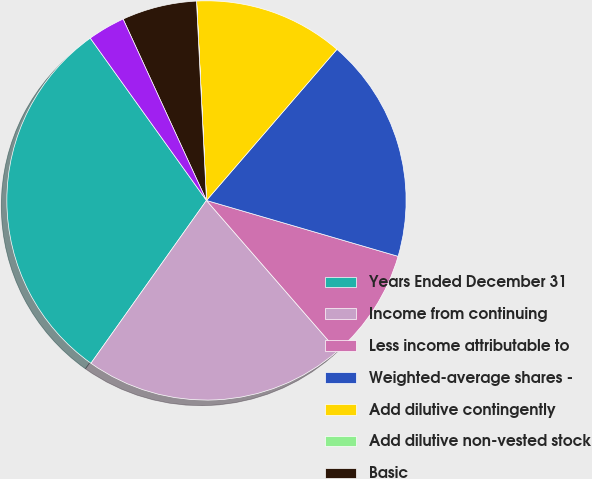Convert chart. <chart><loc_0><loc_0><loc_500><loc_500><pie_chart><fcel>Years Ended December 31<fcel>Income from continuing<fcel>Less income attributable to<fcel>Weighted-average shares -<fcel>Add dilutive contingently<fcel>Add dilutive non-vested stock<fcel>Basic<fcel>Diluted<nl><fcel>30.29%<fcel>21.21%<fcel>9.09%<fcel>18.18%<fcel>12.12%<fcel>0.01%<fcel>6.06%<fcel>3.03%<nl></chart> 